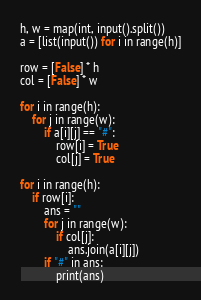Convert code to text. <code><loc_0><loc_0><loc_500><loc_500><_Python_>h, w = map(int, input().split())
a = [list(input()) for i in range(h)]

row = [False] * h
col = [False] * w

for i in range(h):
    for j in range(w):
        if a[i][j] == "#":
            row[i] = True
            col[j] = True

for i in range(h):
    if row[i]:
        ans = ""
        for j in range(w):
            if col[j]:
                ans.join(a[i][j])
        if "#" in ans:
            print(ans)</code> 